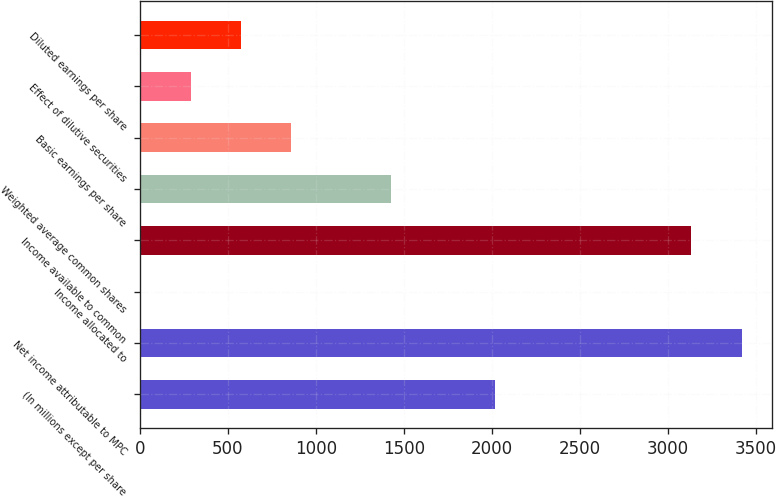Convert chart to OTSL. <chart><loc_0><loc_0><loc_500><loc_500><bar_chart><fcel>(In millions except per share<fcel>Net income attributable to MPC<fcel>Income allocated to<fcel>Income available to common<fcel>Weighted average common shares<fcel>Basic earnings per share<fcel>Effect of dilutive securities<fcel>Diluted earnings per share<nl><fcel>2015<fcel>3417.6<fcel>4<fcel>3132.8<fcel>1428<fcel>858.4<fcel>288.8<fcel>573.6<nl></chart> 